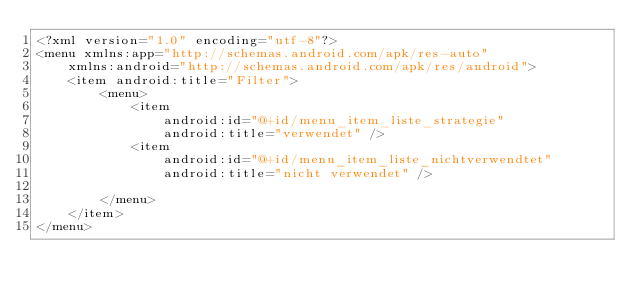<code> <loc_0><loc_0><loc_500><loc_500><_XML_><?xml version="1.0" encoding="utf-8"?>
<menu xmlns:app="http://schemas.android.com/apk/res-auto"
    xmlns:android="http://schemas.android.com/apk/res/android">
    <item android:title="Filter">
        <menu>
            <item
                android:id="@+id/menu_item_liste_strategie"
                android:title="verwendet" />
            <item
                android:id="@+id/menu_item_liste_nichtverwendtet"
                android:title="nicht verwendet" />

        </menu>
    </item>
</menu></code> 